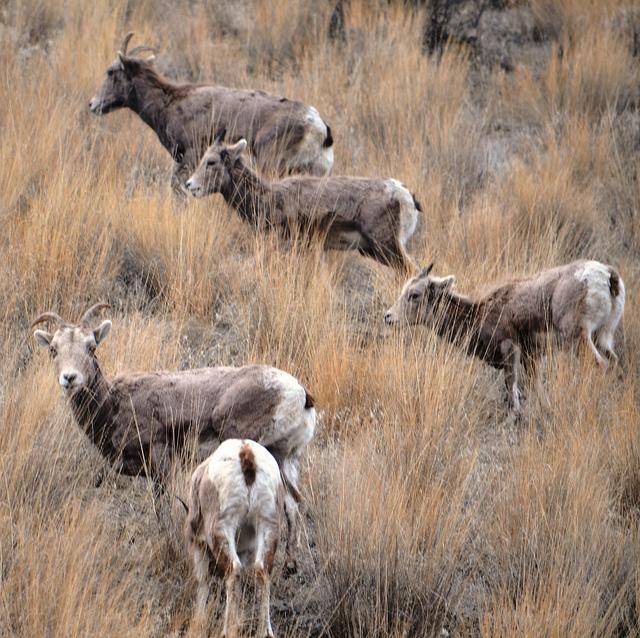Is the grass green?
Concise answer only. No. Does the goat have horns?
Be succinct. Yes. How many goats are in this scene?
Keep it brief. 5. 